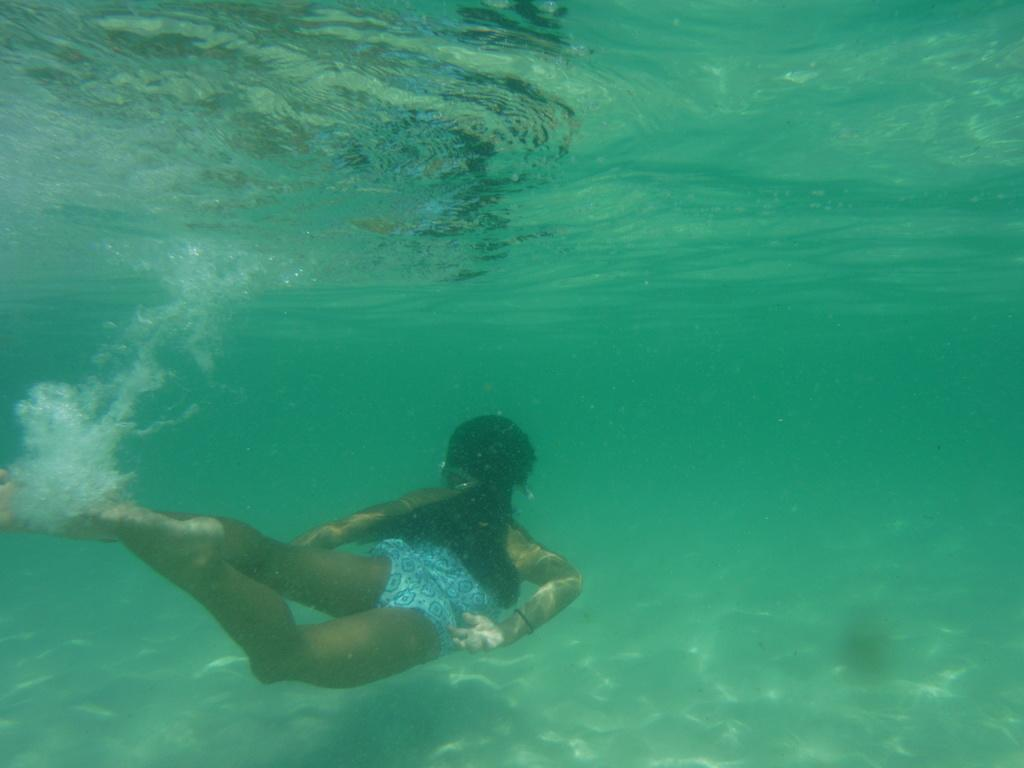What is the main subject of the image? There is a person in the water. Can you describe the person's surroundings? The person is in the water, but we cannot determine the exact location or environment from the given fact. What type of books can be seen in the library in the image? There is no library present in the image, as it only mentions a person in the water. How many passengers are visible in the image? There is no reference to passengers or any other people in the image, as it only mentions a person in the water. 